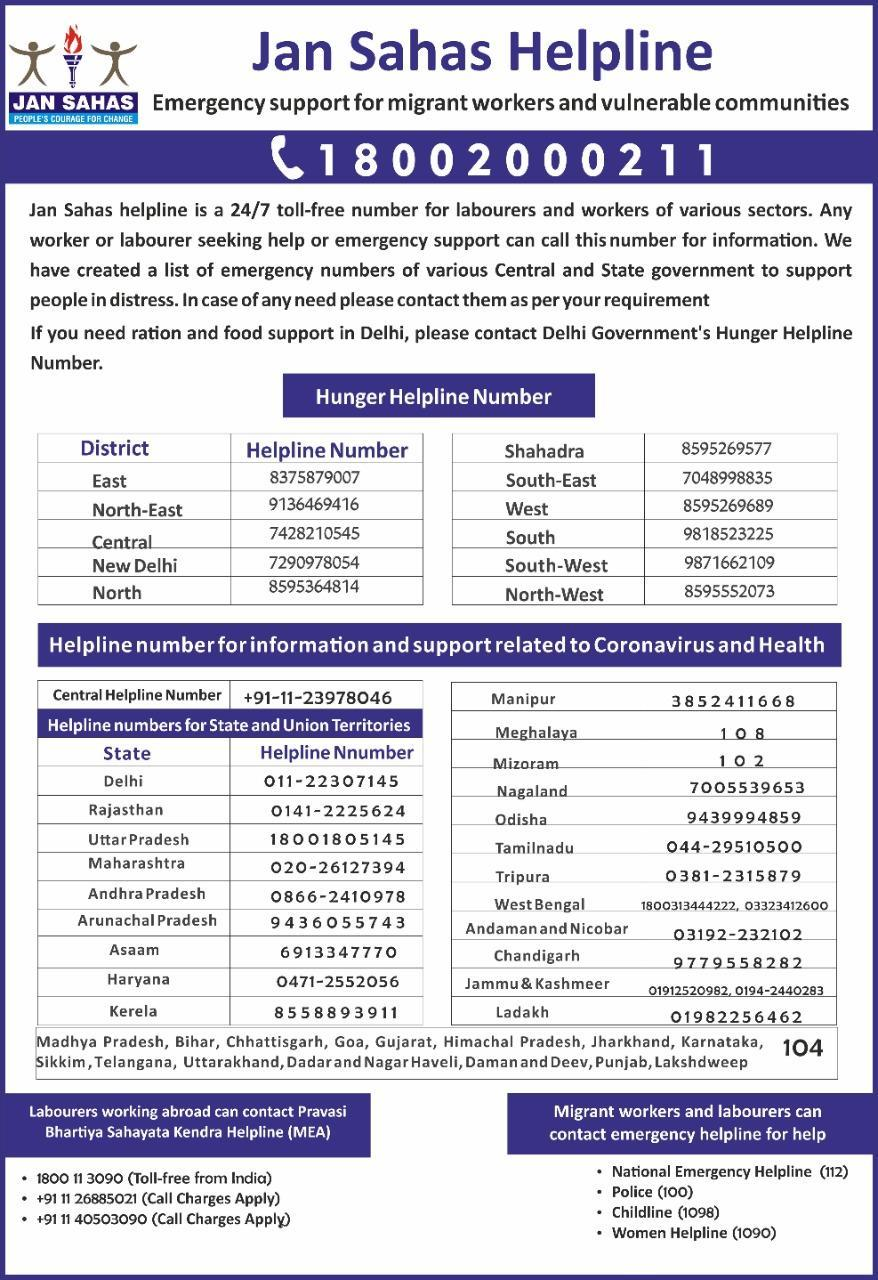How many phone numbers are given in total?
Answer the question with a short phrase. 44 Which number can be called for information in Bihar and Punjab? 104 